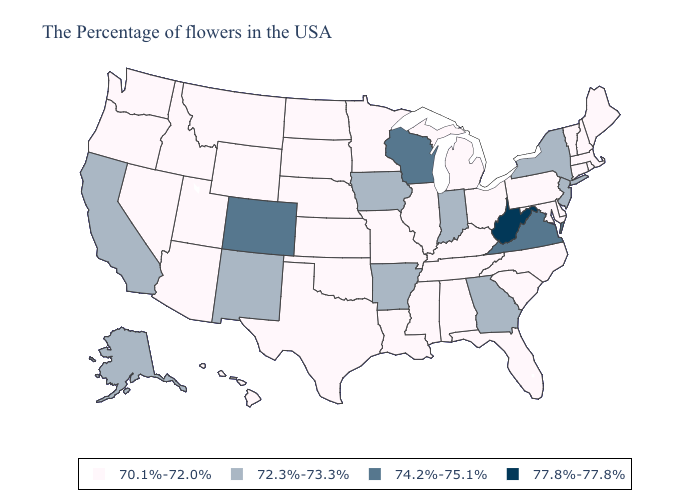What is the value of Tennessee?
Quick response, please. 70.1%-72.0%. What is the value of Georgia?
Short answer required. 72.3%-73.3%. Name the states that have a value in the range 72.3%-73.3%?
Keep it brief. New York, New Jersey, Georgia, Indiana, Arkansas, Iowa, New Mexico, California, Alaska. Does Georgia have the lowest value in the USA?
Give a very brief answer. No. Name the states that have a value in the range 70.1%-72.0%?
Keep it brief. Maine, Massachusetts, Rhode Island, New Hampshire, Vermont, Connecticut, Delaware, Maryland, Pennsylvania, North Carolina, South Carolina, Ohio, Florida, Michigan, Kentucky, Alabama, Tennessee, Illinois, Mississippi, Louisiana, Missouri, Minnesota, Kansas, Nebraska, Oklahoma, Texas, South Dakota, North Dakota, Wyoming, Utah, Montana, Arizona, Idaho, Nevada, Washington, Oregon, Hawaii. Does the map have missing data?
Keep it brief. No. What is the value of New Hampshire?
Write a very short answer. 70.1%-72.0%. Name the states that have a value in the range 70.1%-72.0%?
Give a very brief answer. Maine, Massachusetts, Rhode Island, New Hampshire, Vermont, Connecticut, Delaware, Maryland, Pennsylvania, North Carolina, South Carolina, Ohio, Florida, Michigan, Kentucky, Alabama, Tennessee, Illinois, Mississippi, Louisiana, Missouri, Minnesota, Kansas, Nebraska, Oklahoma, Texas, South Dakota, North Dakota, Wyoming, Utah, Montana, Arizona, Idaho, Nevada, Washington, Oregon, Hawaii. Does Louisiana have a lower value than Georgia?
Concise answer only. Yes. Does West Virginia have the highest value in the USA?
Quick response, please. Yes. Does New Mexico have the lowest value in the West?
Concise answer only. No. Name the states that have a value in the range 77.8%-77.8%?
Short answer required. West Virginia. How many symbols are there in the legend?
Keep it brief. 4. Name the states that have a value in the range 70.1%-72.0%?
Short answer required. Maine, Massachusetts, Rhode Island, New Hampshire, Vermont, Connecticut, Delaware, Maryland, Pennsylvania, North Carolina, South Carolina, Ohio, Florida, Michigan, Kentucky, Alabama, Tennessee, Illinois, Mississippi, Louisiana, Missouri, Minnesota, Kansas, Nebraska, Oklahoma, Texas, South Dakota, North Dakota, Wyoming, Utah, Montana, Arizona, Idaho, Nevada, Washington, Oregon, Hawaii. Which states have the highest value in the USA?
Answer briefly. West Virginia. 